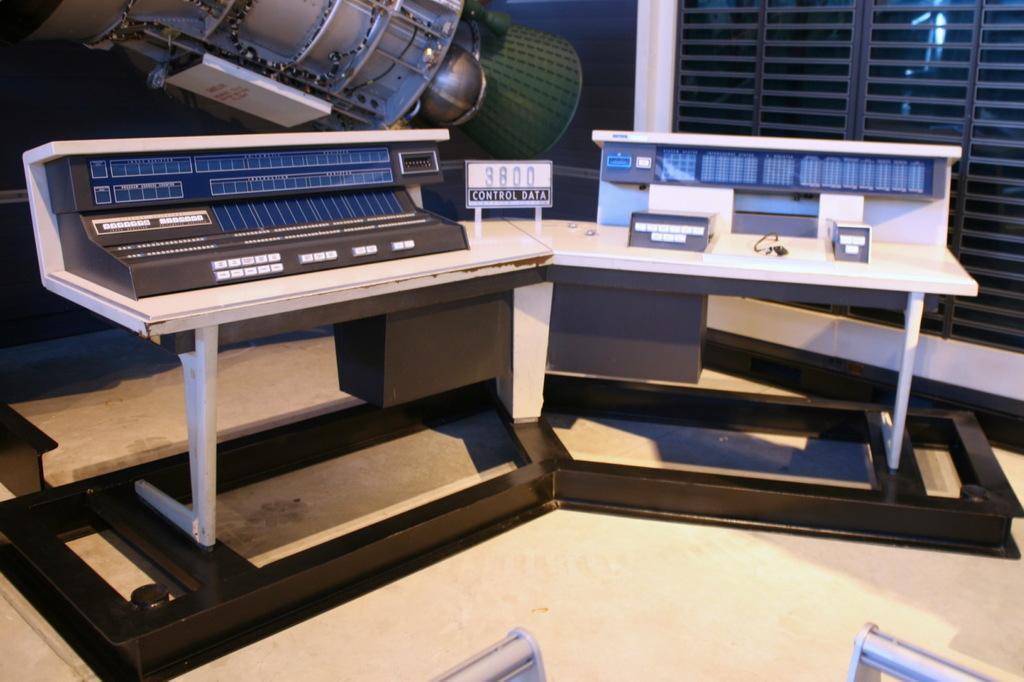In one or two sentences, can you explain what this image depicts? We can see board and objects on tables. Background we can see machine and window. 